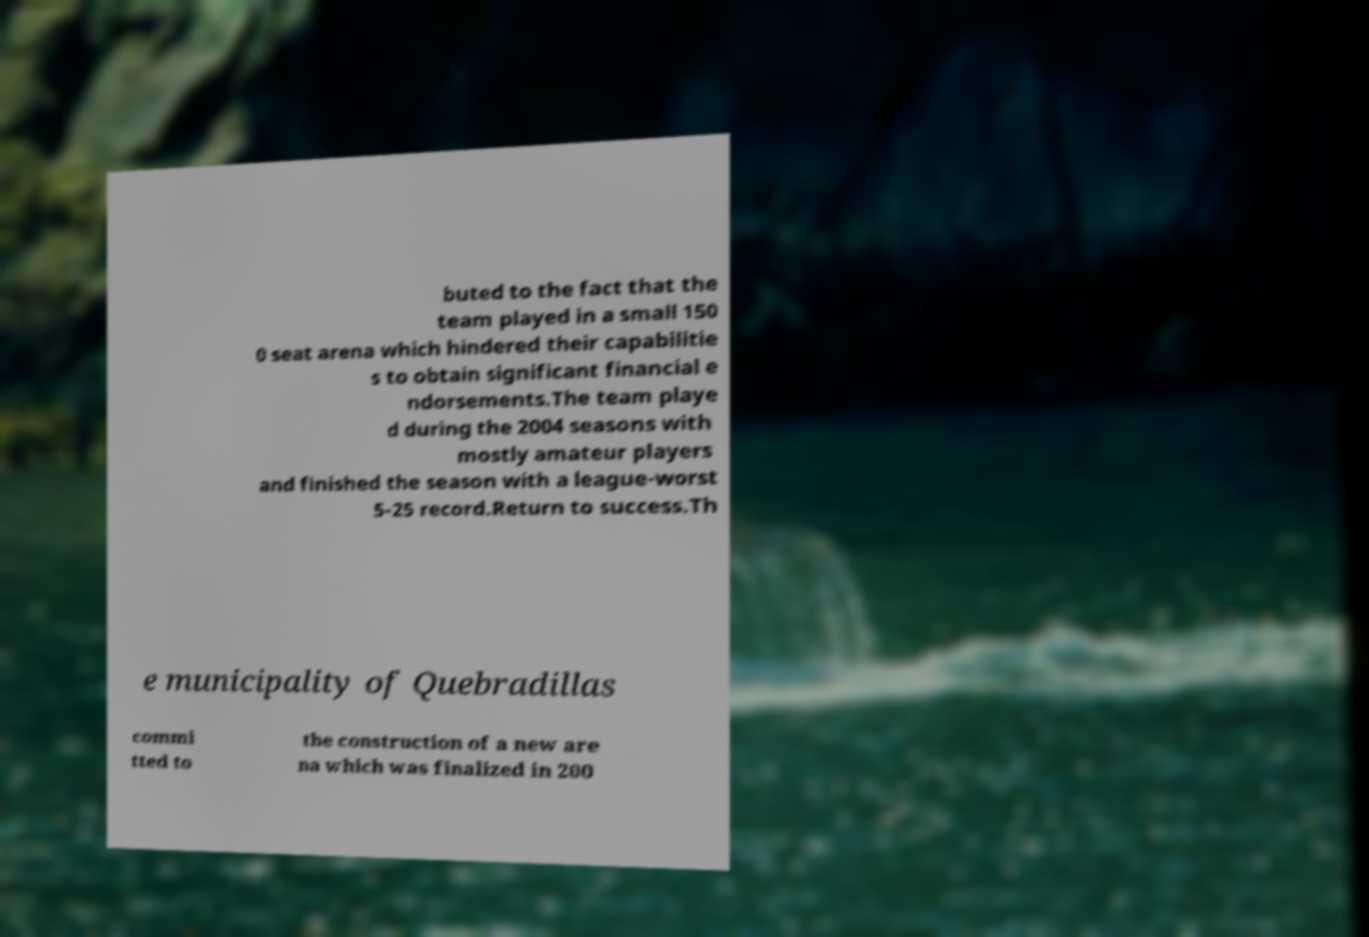Could you assist in decoding the text presented in this image and type it out clearly? buted to the fact that the team played in a small 150 0 seat arena which hindered their capabilitie s to obtain significant financial e ndorsements.The team playe d during the 2004 seasons with mostly amateur players and finished the season with a league-worst 5-25 record.Return to success.Th e municipality of Quebradillas commi tted to the construction of a new are na which was finalized in 200 